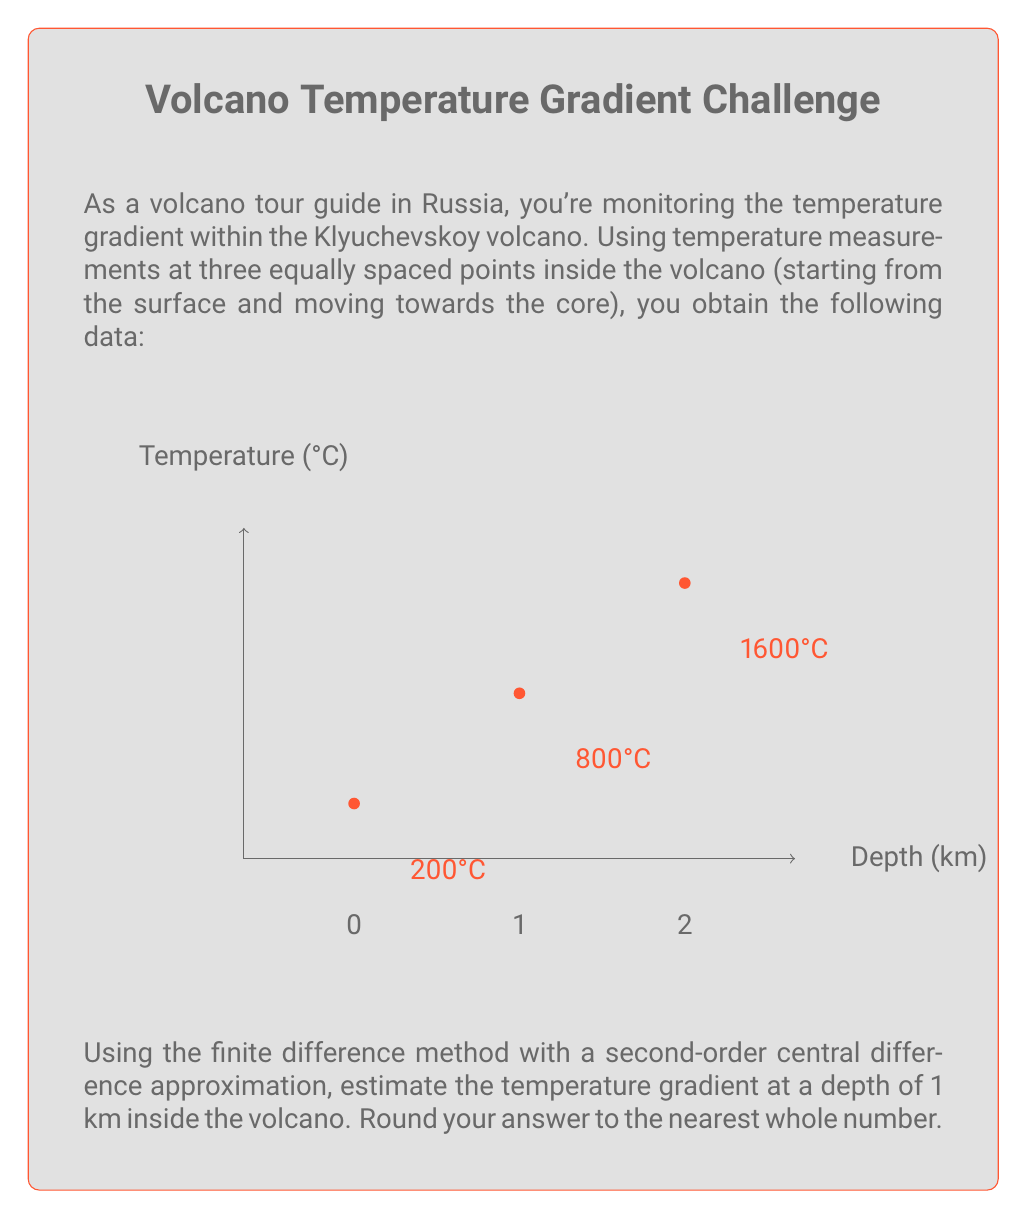Teach me how to tackle this problem. To solve this problem, we'll use the finite difference method with a second-order central difference approximation. The steps are as follows:

1) The general formula for the second-order central difference approximation of the first derivative (temperature gradient in this case) is:

   $$f'(x) \approx \frac{f(x+h) - f(x-h)}{2h}$$

   where $h$ is the step size.

2) In our case:
   - $x = 1$ km (the depth at which we want to calculate the gradient)
   - $h = 1$ km (the step size between measurements)
   - $f(x-h) = 200°C$ (temperature at 0 km depth)
   - $f(x+h) = 1600°C$ (temperature at 2 km depth)

3) Plugging these values into the formula:

   $$f'(1) \approx \frac{1600°C - 200°C}{2(1 \text{ km})} = \frac{1400°C}{2 \text{ km}} = 700°C/\text{km}$$

4) Therefore, the estimated temperature gradient at a depth of 1 km is 700°C/km.

5) Rounding to the nearest whole number: 700°C/km.
Answer: 700°C/km 